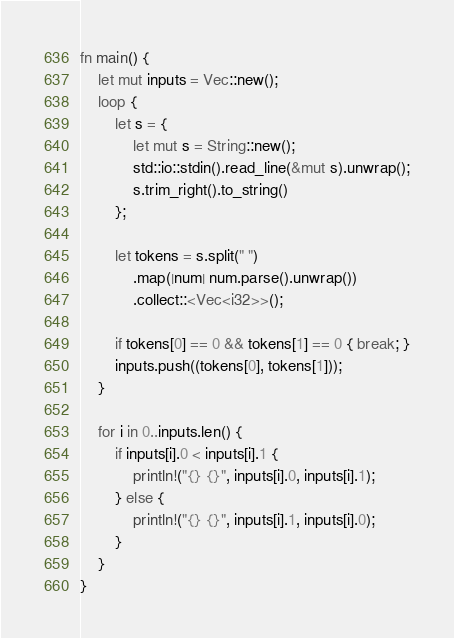Convert code to text. <code><loc_0><loc_0><loc_500><loc_500><_Rust_>fn main() {
    let mut inputs = Vec::new();    
    loop {
        let s = {
            let mut s = String::new(); 
            std::io::stdin().read_line(&mut s).unwrap();
            s.trim_right().to_string()
        };

        let tokens = s.split(" ")
            .map(|num| num.parse().unwrap())
            .collect::<Vec<i32>>();

        if tokens[0] == 0 && tokens[1] == 0 { break; }
        inputs.push((tokens[0], tokens[1]));
    }

    for i in 0..inputs.len() {
        if inputs[i].0 < inputs[i].1 {
            println!("{} {}", inputs[i].0, inputs[i].1);
        } else {
            println!("{} {}", inputs[i].1, inputs[i].0);
        }
    }
}
</code> 